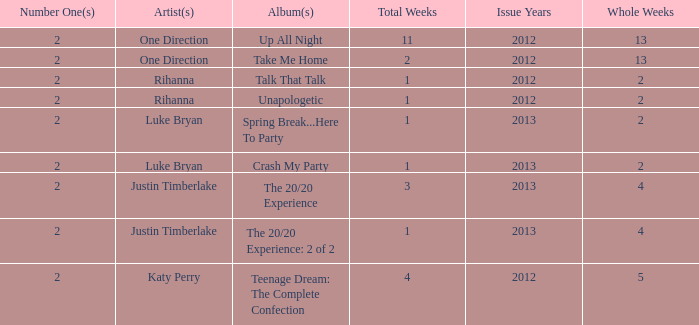What is the title of every song, and how many weeks was each song at #1 for Rihanna in 2012? Talk That Talk — 1, Unapologetic — 1. 